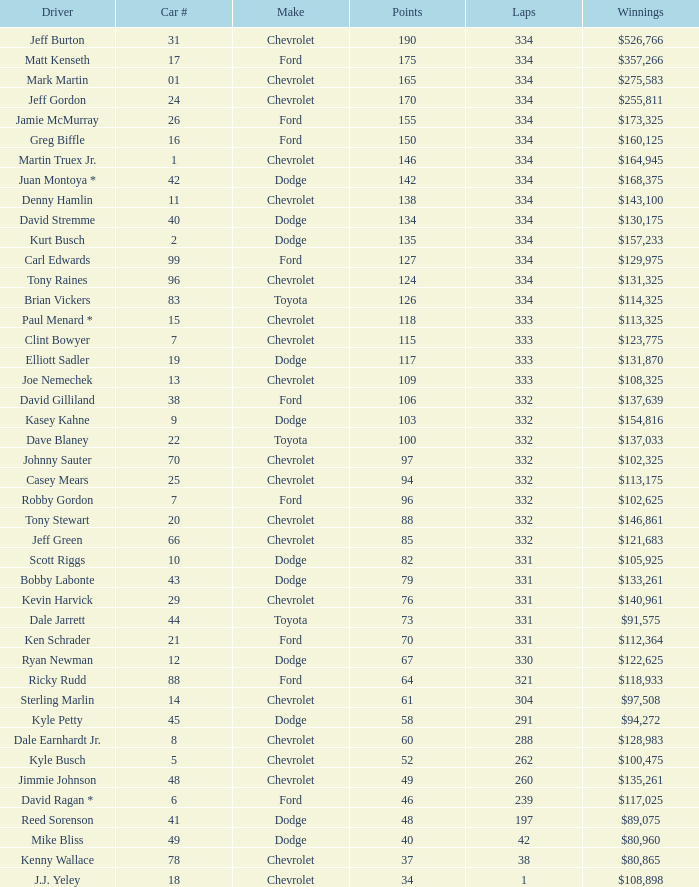Would you be able to parse every entry in this table? {'header': ['Driver', 'Car #', 'Make', 'Points', 'Laps', 'Winnings'], 'rows': [['Jeff Burton', '31', 'Chevrolet', '190', '334', '$526,766'], ['Matt Kenseth', '17', 'Ford', '175', '334', '$357,266'], ['Mark Martin', '01', 'Chevrolet', '165', '334', '$275,583'], ['Jeff Gordon', '24', 'Chevrolet', '170', '334', '$255,811'], ['Jamie McMurray', '26', 'Ford', '155', '334', '$173,325'], ['Greg Biffle', '16', 'Ford', '150', '334', '$160,125'], ['Martin Truex Jr.', '1', 'Chevrolet', '146', '334', '$164,945'], ['Juan Montoya *', '42', 'Dodge', '142', '334', '$168,375'], ['Denny Hamlin', '11', 'Chevrolet', '138', '334', '$143,100'], ['David Stremme', '40', 'Dodge', '134', '334', '$130,175'], ['Kurt Busch', '2', 'Dodge', '135', '334', '$157,233'], ['Carl Edwards', '99', 'Ford', '127', '334', '$129,975'], ['Tony Raines', '96', 'Chevrolet', '124', '334', '$131,325'], ['Brian Vickers', '83', 'Toyota', '126', '334', '$114,325'], ['Paul Menard *', '15', 'Chevrolet', '118', '333', '$113,325'], ['Clint Bowyer', '7', 'Chevrolet', '115', '333', '$123,775'], ['Elliott Sadler', '19', 'Dodge', '117', '333', '$131,870'], ['Joe Nemechek', '13', 'Chevrolet', '109', '333', '$108,325'], ['David Gilliland', '38', 'Ford', '106', '332', '$137,639'], ['Kasey Kahne', '9', 'Dodge', '103', '332', '$154,816'], ['Dave Blaney', '22', 'Toyota', '100', '332', '$137,033'], ['Johnny Sauter', '70', 'Chevrolet', '97', '332', '$102,325'], ['Casey Mears', '25', 'Chevrolet', '94', '332', '$113,175'], ['Robby Gordon', '7', 'Ford', '96', '332', '$102,625'], ['Tony Stewart', '20', 'Chevrolet', '88', '332', '$146,861'], ['Jeff Green', '66', 'Chevrolet', '85', '332', '$121,683'], ['Scott Riggs', '10', 'Dodge', '82', '331', '$105,925'], ['Bobby Labonte', '43', 'Dodge', '79', '331', '$133,261'], ['Kevin Harvick', '29', 'Chevrolet', '76', '331', '$140,961'], ['Dale Jarrett', '44', 'Toyota', '73', '331', '$91,575'], ['Ken Schrader', '21', 'Ford', '70', '331', '$112,364'], ['Ryan Newman', '12', 'Dodge', '67', '330', '$122,625'], ['Ricky Rudd', '88', 'Ford', '64', '321', '$118,933'], ['Sterling Marlin', '14', 'Chevrolet', '61', '304', '$97,508'], ['Kyle Petty', '45', 'Dodge', '58', '291', '$94,272'], ['Dale Earnhardt Jr.', '8', 'Chevrolet', '60', '288', '$128,983'], ['Kyle Busch', '5', 'Chevrolet', '52', '262', '$100,475'], ['Jimmie Johnson', '48', 'Chevrolet', '49', '260', '$135,261'], ['David Ragan *', '6', 'Ford', '46', '239', '$117,025'], ['Reed Sorenson', '41', 'Dodge', '48', '197', '$89,075'], ['Mike Bliss', '49', 'Dodge', '40', '42', '$80,960'], ['Kenny Wallace', '78', 'Chevrolet', '37', '38', '$80,865'], ['J.J. Yeley', '18', 'Chevrolet', '34', '1', '$108,898']]} How many total laps did the Chevrolet that won $97,508 make? 1.0. 